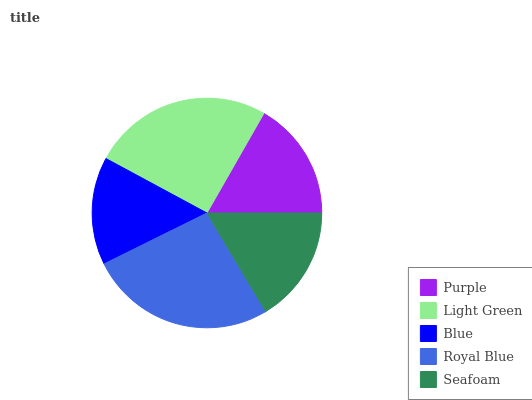Is Blue the minimum?
Answer yes or no. Yes. Is Royal Blue the maximum?
Answer yes or no. Yes. Is Light Green the minimum?
Answer yes or no. No. Is Light Green the maximum?
Answer yes or no. No. Is Light Green greater than Purple?
Answer yes or no. Yes. Is Purple less than Light Green?
Answer yes or no. Yes. Is Purple greater than Light Green?
Answer yes or no. No. Is Light Green less than Purple?
Answer yes or no. No. Is Purple the high median?
Answer yes or no. Yes. Is Purple the low median?
Answer yes or no. Yes. Is Royal Blue the high median?
Answer yes or no. No. Is Royal Blue the low median?
Answer yes or no. No. 